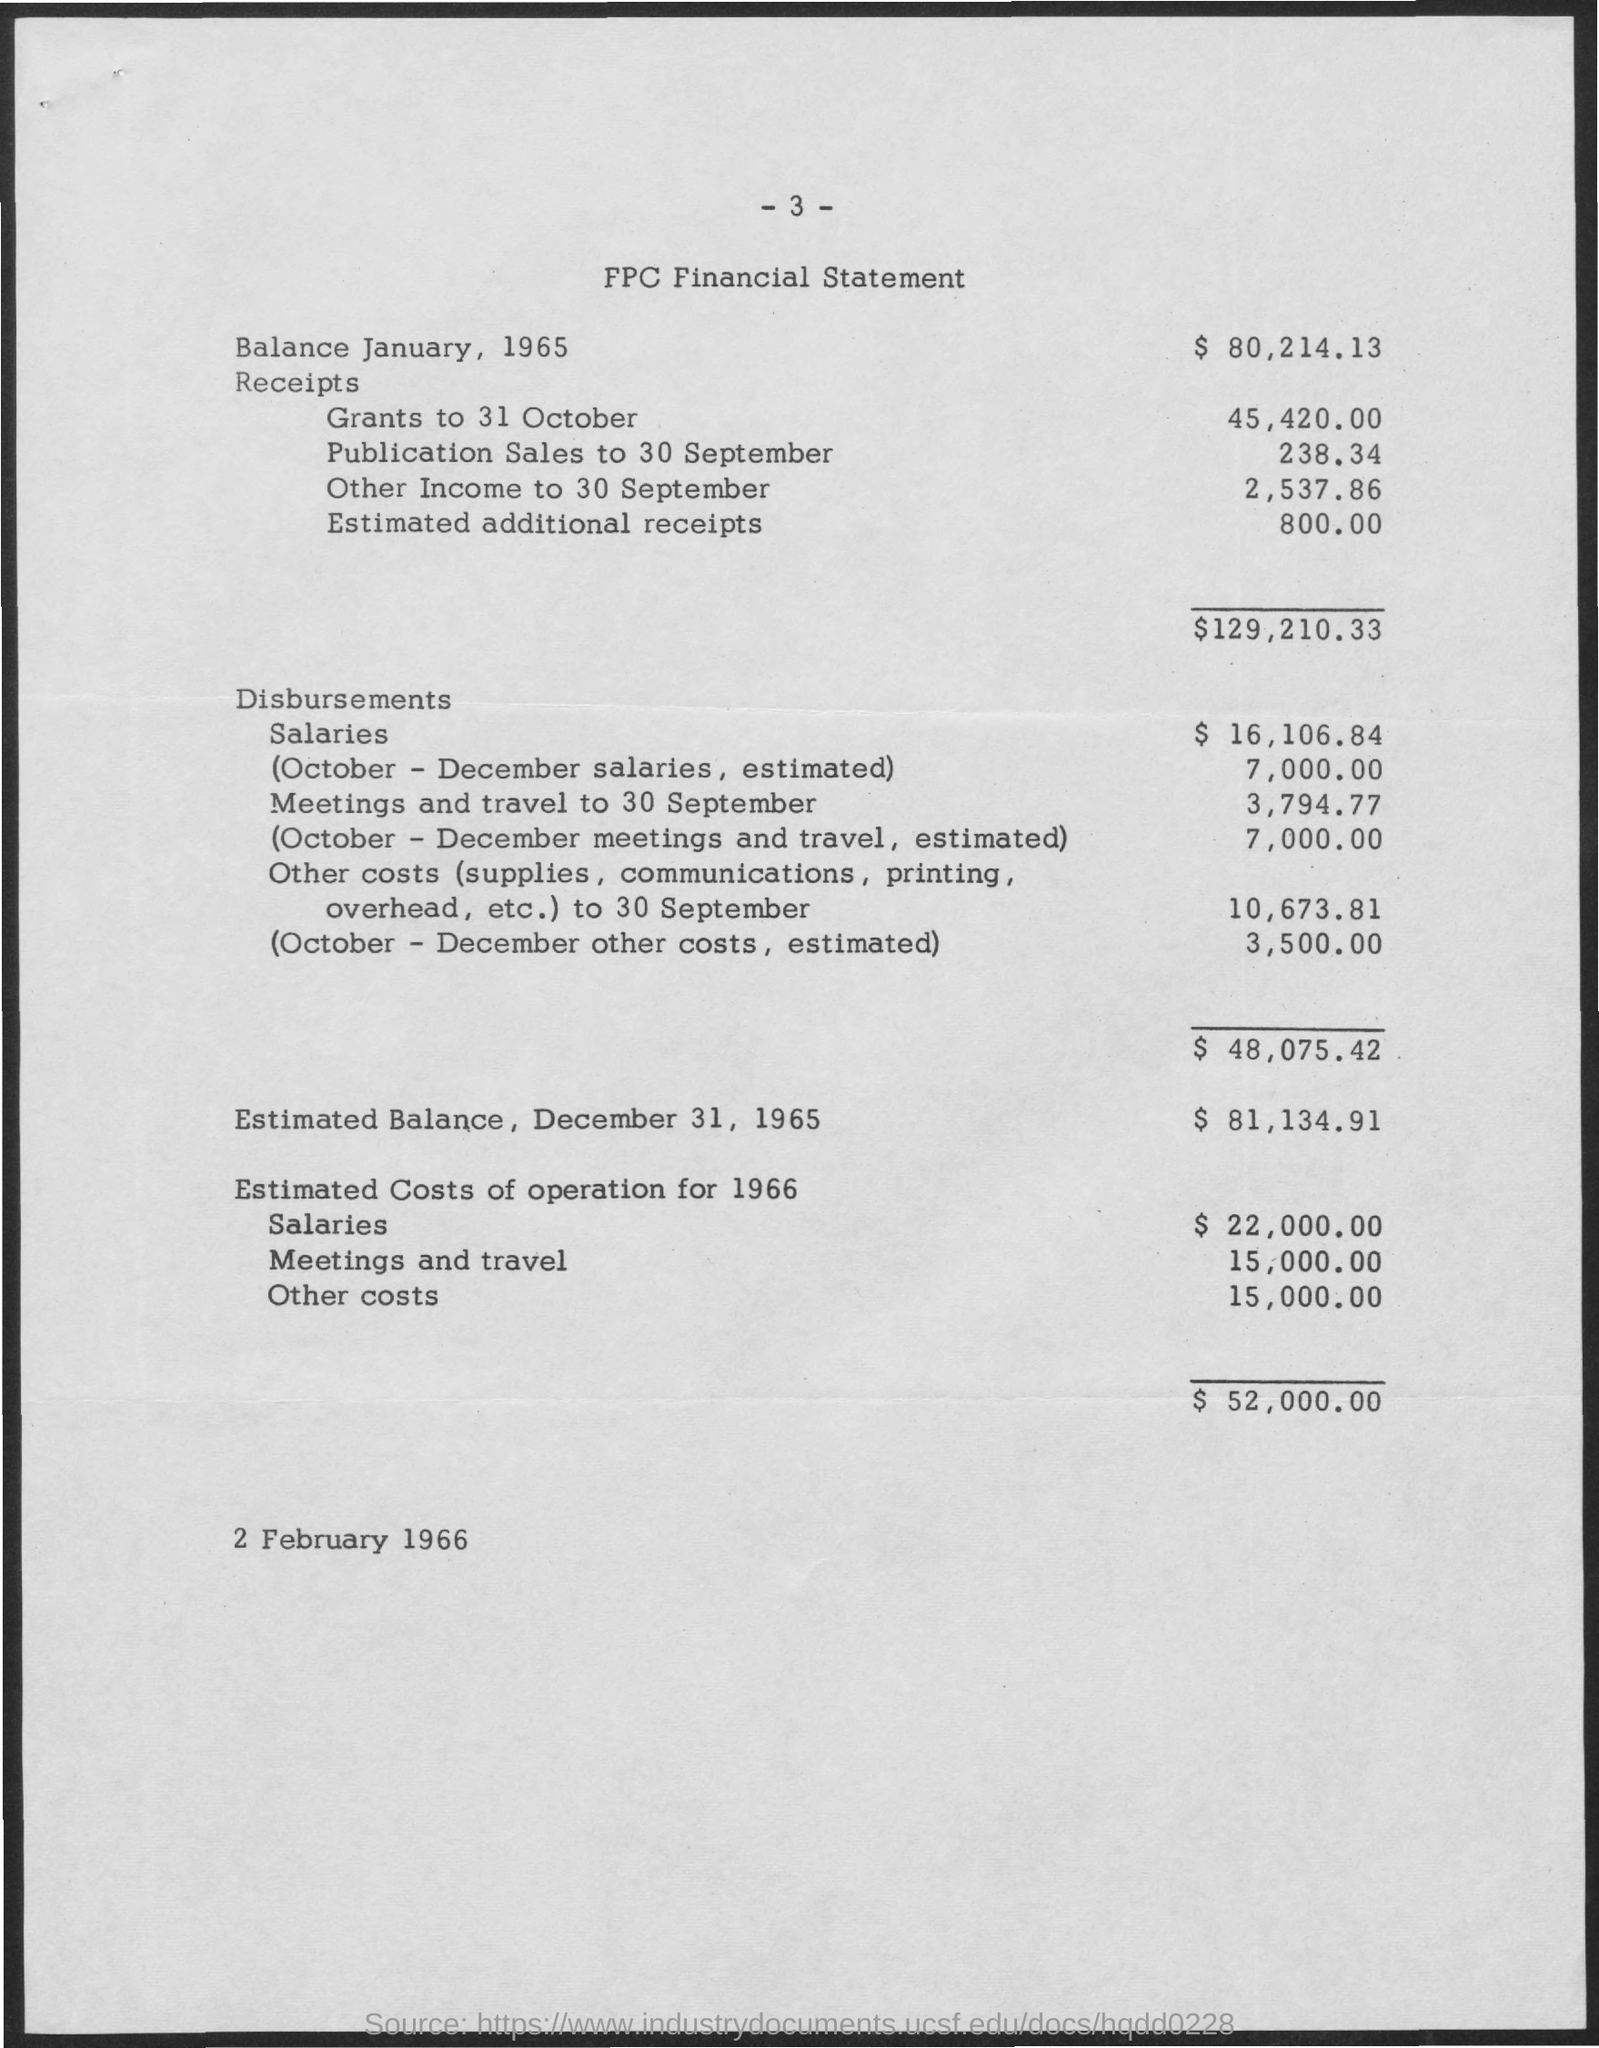Draw attention to some important aspects in this diagram. As of January 1965, the balance was $80,214.13. The estimated balance as of December 31, 1965 was $81,134.91. 